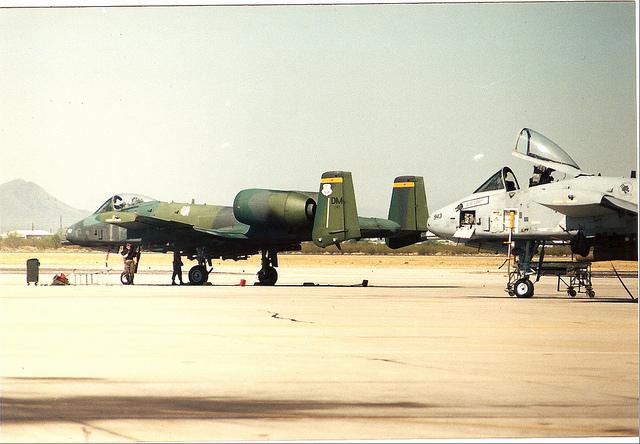How many engines does the first plane have?
Write a very short answer. 2. What type of planes are in the photo?
Give a very brief answer. Military. Are the planes in flight?
Concise answer only. No. 